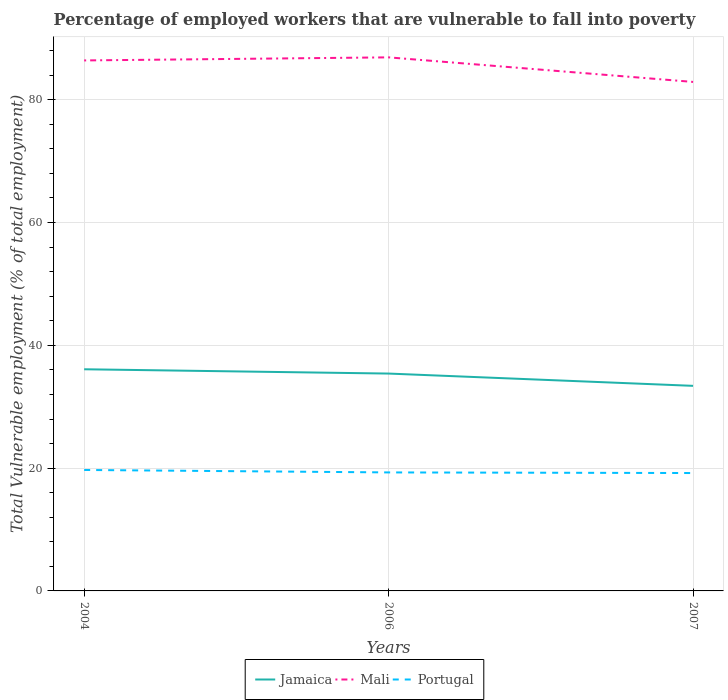Is the number of lines equal to the number of legend labels?
Offer a terse response. Yes. Across all years, what is the maximum percentage of employed workers who are vulnerable to fall into poverty in Jamaica?
Offer a terse response. 33.4. What is the total percentage of employed workers who are vulnerable to fall into poverty in Jamaica in the graph?
Your response must be concise. 2.7. What is the difference between the highest and the second highest percentage of employed workers who are vulnerable to fall into poverty in Jamaica?
Give a very brief answer. 2.7. Is the percentage of employed workers who are vulnerable to fall into poverty in Mali strictly greater than the percentage of employed workers who are vulnerable to fall into poverty in Portugal over the years?
Keep it short and to the point. No. How many lines are there?
Your answer should be very brief. 3. What is the difference between two consecutive major ticks on the Y-axis?
Ensure brevity in your answer.  20. Are the values on the major ticks of Y-axis written in scientific E-notation?
Offer a terse response. No. Does the graph contain any zero values?
Offer a terse response. No. How many legend labels are there?
Your answer should be very brief. 3. How are the legend labels stacked?
Keep it short and to the point. Horizontal. What is the title of the graph?
Make the answer very short. Percentage of employed workers that are vulnerable to fall into poverty. What is the label or title of the Y-axis?
Provide a succinct answer. Total Vulnerable employment (% of total employment). What is the Total Vulnerable employment (% of total employment) in Jamaica in 2004?
Your answer should be very brief. 36.1. What is the Total Vulnerable employment (% of total employment) in Mali in 2004?
Your answer should be compact. 86.4. What is the Total Vulnerable employment (% of total employment) in Portugal in 2004?
Your response must be concise. 19.7. What is the Total Vulnerable employment (% of total employment) in Jamaica in 2006?
Your answer should be very brief. 35.4. What is the Total Vulnerable employment (% of total employment) in Mali in 2006?
Your answer should be very brief. 86.9. What is the Total Vulnerable employment (% of total employment) in Portugal in 2006?
Keep it short and to the point. 19.3. What is the Total Vulnerable employment (% of total employment) of Jamaica in 2007?
Provide a succinct answer. 33.4. What is the Total Vulnerable employment (% of total employment) in Mali in 2007?
Ensure brevity in your answer.  82.9. What is the Total Vulnerable employment (% of total employment) in Portugal in 2007?
Ensure brevity in your answer.  19.2. Across all years, what is the maximum Total Vulnerable employment (% of total employment) in Jamaica?
Your answer should be compact. 36.1. Across all years, what is the maximum Total Vulnerable employment (% of total employment) of Mali?
Provide a succinct answer. 86.9. Across all years, what is the maximum Total Vulnerable employment (% of total employment) in Portugal?
Give a very brief answer. 19.7. Across all years, what is the minimum Total Vulnerable employment (% of total employment) of Jamaica?
Give a very brief answer. 33.4. Across all years, what is the minimum Total Vulnerable employment (% of total employment) in Mali?
Offer a very short reply. 82.9. Across all years, what is the minimum Total Vulnerable employment (% of total employment) in Portugal?
Keep it short and to the point. 19.2. What is the total Total Vulnerable employment (% of total employment) in Jamaica in the graph?
Provide a succinct answer. 104.9. What is the total Total Vulnerable employment (% of total employment) of Mali in the graph?
Ensure brevity in your answer.  256.2. What is the total Total Vulnerable employment (% of total employment) of Portugal in the graph?
Your response must be concise. 58.2. What is the difference between the Total Vulnerable employment (% of total employment) of Mali in 2004 and that in 2006?
Provide a succinct answer. -0.5. What is the difference between the Total Vulnerable employment (% of total employment) of Jamaica in 2004 and that in 2007?
Keep it short and to the point. 2.7. What is the difference between the Total Vulnerable employment (% of total employment) of Mali in 2004 and that in 2007?
Keep it short and to the point. 3.5. What is the difference between the Total Vulnerable employment (% of total employment) of Portugal in 2004 and that in 2007?
Your response must be concise. 0.5. What is the difference between the Total Vulnerable employment (% of total employment) of Jamaica in 2004 and the Total Vulnerable employment (% of total employment) of Mali in 2006?
Your answer should be very brief. -50.8. What is the difference between the Total Vulnerable employment (% of total employment) in Jamaica in 2004 and the Total Vulnerable employment (% of total employment) in Portugal in 2006?
Provide a short and direct response. 16.8. What is the difference between the Total Vulnerable employment (% of total employment) of Mali in 2004 and the Total Vulnerable employment (% of total employment) of Portugal in 2006?
Ensure brevity in your answer.  67.1. What is the difference between the Total Vulnerable employment (% of total employment) of Jamaica in 2004 and the Total Vulnerable employment (% of total employment) of Mali in 2007?
Provide a succinct answer. -46.8. What is the difference between the Total Vulnerable employment (% of total employment) of Jamaica in 2004 and the Total Vulnerable employment (% of total employment) of Portugal in 2007?
Give a very brief answer. 16.9. What is the difference between the Total Vulnerable employment (% of total employment) of Mali in 2004 and the Total Vulnerable employment (% of total employment) of Portugal in 2007?
Provide a short and direct response. 67.2. What is the difference between the Total Vulnerable employment (% of total employment) in Jamaica in 2006 and the Total Vulnerable employment (% of total employment) in Mali in 2007?
Ensure brevity in your answer.  -47.5. What is the difference between the Total Vulnerable employment (% of total employment) in Mali in 2006 and the Total Vulnerable employment (% of total employment) in Portugal in 2007?
Provide a succinct answer. 67.7. What is the average Total Vulnerable employment (% of total employment) of Jamaica per year?
Your answer should be compact. 34.97. What is the average Total Vulnerable employment (% of total employment) in Mali per year?
Your response must be concise. 85.4. In the year 2004, what is the difference between the Total Vulnerable employment (% of total employment) in Jamaica and Total Vulnerable employment (% of total employment) in Mali?
Give a very brief answer. -50.3. In the year 2004, what is the difference between the Total Vulnerable employment (% of total employment) in Mali and Total Vulnerable employment (% of total employment) in Portugal?
Ensure brevity in your answer.  66.7. In the year 2006, what is the difference between the Total Vulnerable employment (% of total employment) of Jamaica and Total Vulnerable employment (% of total employment) of Mali?
Make the answer very short. -51.5. In the year 2006, what is the difference between the Total Vulnerable employment (% of total employment) of Jamaica and Total Vulnerable employment (% of total employment) of Portugal?
Offer a very short reply. 16.1. In the year 2006, what is the difference between the Total Vulnerable employment (% of total employment) of Mali and Total Vulnerable employment (% of total employment) of Portugal?
Ensure brevity in your answer.  67.6. In the year 2007, what is the difference between the Total Vulnerable employment (% of total employment) in Jamaica and Total Vulnerable employment (% of total employment) in Mali?
Keep it short and to the point. -49.5. In the year 2007, what is the difference between the Total Vulnerable employment (% of total employment) of Mali and Total Vulnerable employment (% of total employment) of Portugal?
Provide a succinct answer. 63.7. What is the ratio of the Total Vulnerable employment (% of total employment) in Jamaica in 2004 to that in 2006?
Your response must be concise. 1.02. What is the ratio of the Total Vulnerable employment (% of total employment) of Mali in 2004 to that in 2006?
Your answer should be compact. 0.99. What is the ratio of the Total Vulnerable employment (% of total employment) of Portugal in 2004 to that in 2006?
Offer a very short reply. 1.02. What is the ratio of the Total Vulnerable employment (% of total employment) of Jamaica in 2004 to that in 2007?
Offer a terse response. 1.08. What is the ratio of the Total Vulnerable employment (% of total employment) of Mali in 2004 to that in 2007?
Offer a terse response. 1.04. What is the ratio of the Total Vulnerable employment (% of total employment) of Jamaica in 2006 to that in 2007?
Keep it short and to the point. 1.06. What is the ratio of the Total Vulnerable employment (% of total employment) in Mali in 2006 to that in 2007?
Offer a terse response. 1.05. What is the ratio of the Total Vulnerable employment (% of total employment) in Portugal in 2006 to that in 2007?
Give a very brief answer. 1.01. What is the difference between the highest and the second highest Total Vulnerable employment (% of total employment) of Jamaica?
Offer a very short reply. 0.7. What is the difference between the highest and the second highest Total Vulnerable employment (% of total employment) in Mali?
Your answer should be compact. 0.5. What is the difference between the highest and the second highest Total Vulnerable employment (% of total employment) of Portugal?
Ensure brevity in your answer.  0.4. What is the difference between the highest and the lowest Total Vulnerable employment (% of total employment) in Jamaica?
Your answer should be very brief. 2.7. 